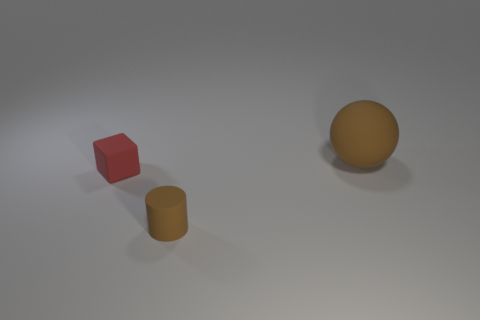Add 2 large spheres. How many objects exist? 5 Subtract all blocks. How many objects are left? 2 Add 3 red rubber cubes. How many red rubber cubes are left? 4 Add 2 large rubber balls. How many large rubber balls exist? 3 Subtract 0 red cylinders. How many objects are left? 3 Subtract all big red balls. Subtract all brown spheres. How many objects are left? 2 